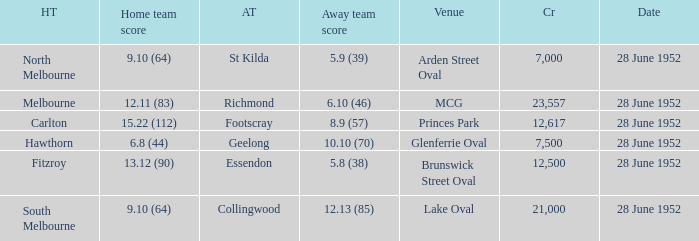What is the home team's score when the venue is princes park? 15.22 (112). 